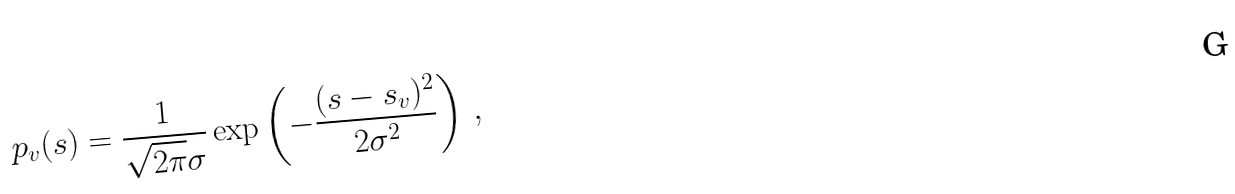Convert formula to latex. <formula><loc_0><loc_0><loc_500><loc_500>p _ { v } ( s ) = \frac { 1 } { \sqrt { 2 \pi } \sigma } \exp \left ( - \frac { ( s - s _ { v } ) ^ { 2 } } { 2 \sigma ^ { 2 } } \right ) \, ,</formula> 